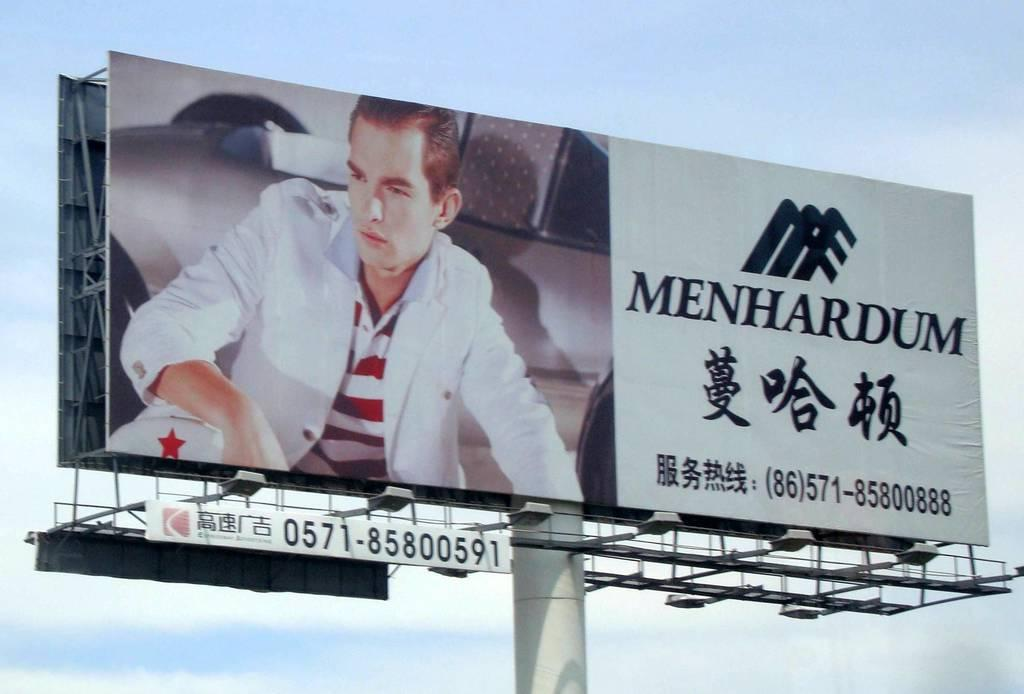<image>
Give a short and clear explanation of the subsequent image. A billboard with a picture of a man and the word Menhardum 